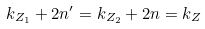<formula> <loc_0><loc_0><loc_500><loc_500>k _ { Z _ { 1 } } + 2 n ^ { \prime } = k _ { Z _ { 2 } } + 2 n = k _ { Z }</formula> 